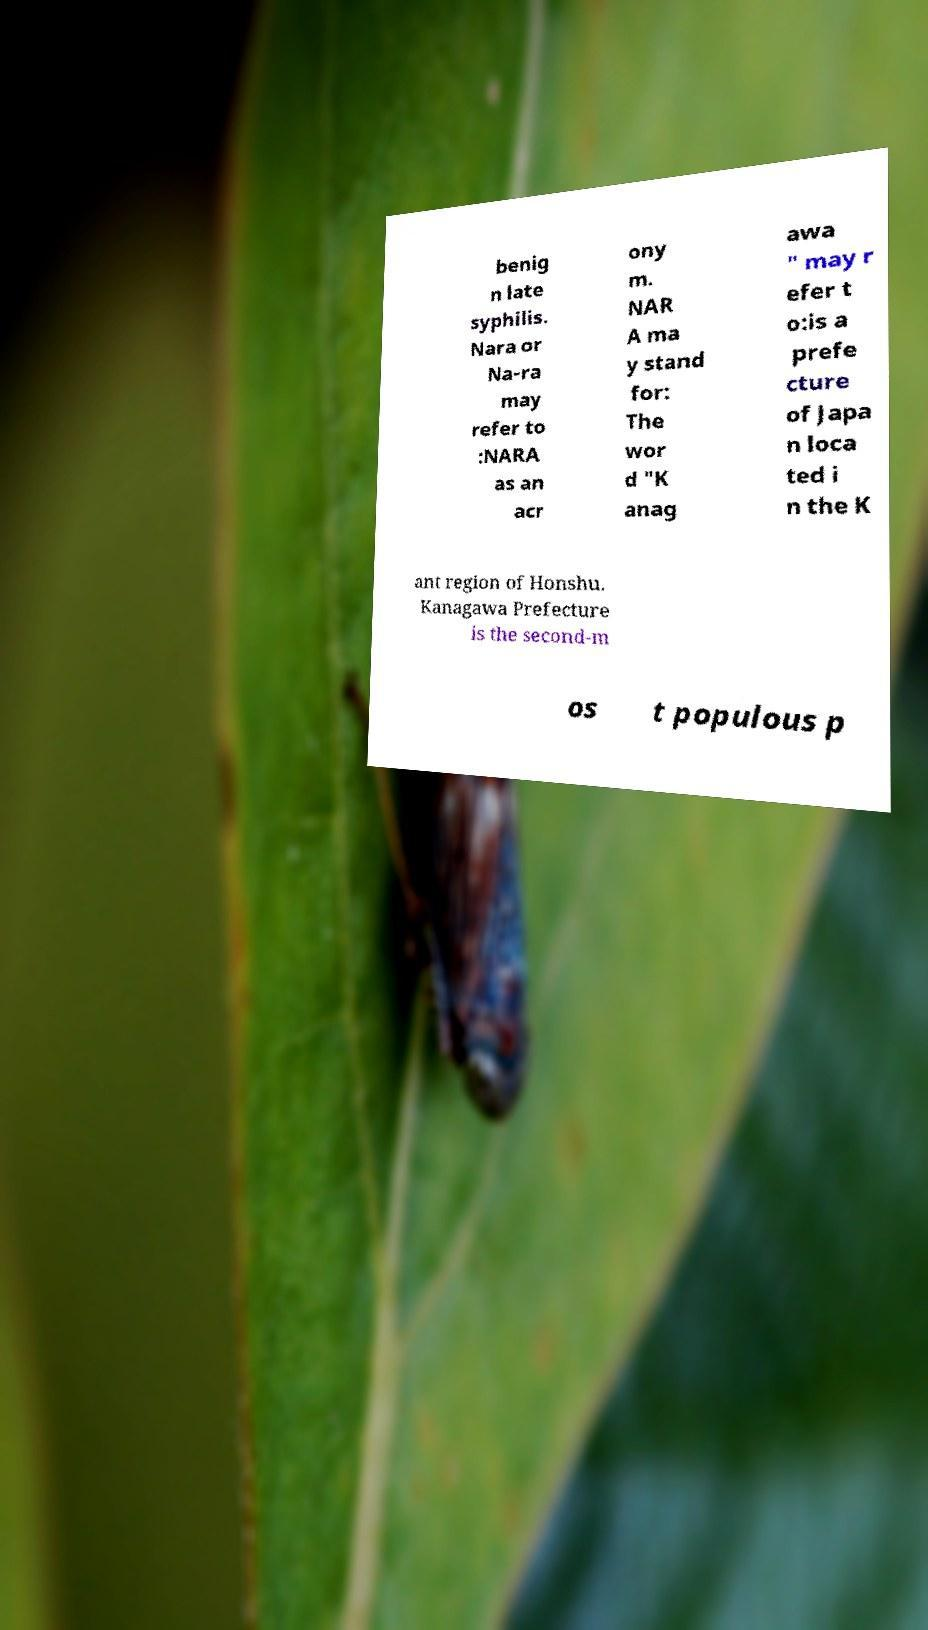There's text embedded in this image that I need extracted. Can you transcribe it verbatim? benig n late syphilis. Nara or Na-ra may refer to :NARA as an acr ony m. NAR A ma y stand for: The wor d "K anag awa " may r efer t o:is a prefe cture of Japa n loca ted i n the K ant region of Honshu. Kanagawa Prefecture is the second-m os t populous p 